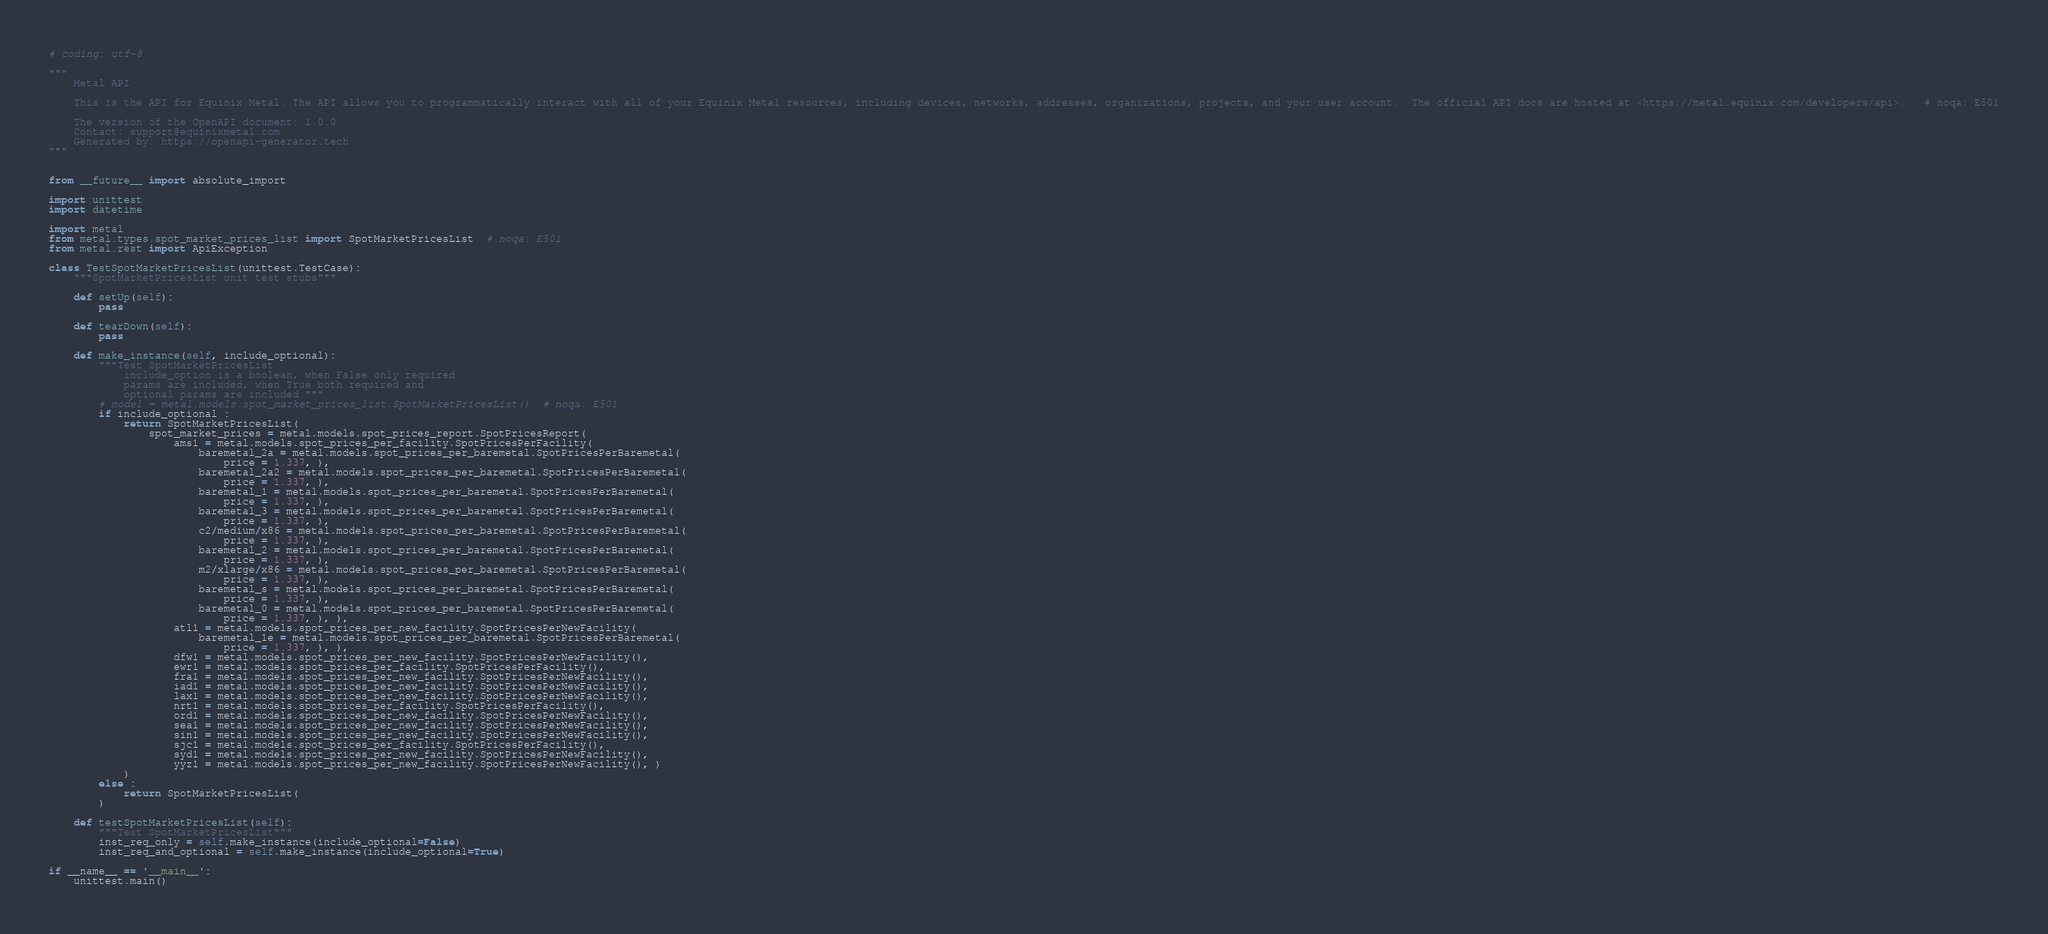<code> <loc_0><loc_0><loc_500><loc_500><_Python_># coding: utf-8

"""
    Metal API

    This is the API for Equinix Metal. The API allows you to programmatically interact with all of your Equinix Metal resources, including devices, networks, addresses, organizations, projects, and your user account.  The official API docs are hosted at <https://metal.equinix.com/developers/api>.   # noqa: E501

    The version of the OpenAPI document: 1.0.0
    Contact: support@equinixmetal.com
    Generated by: https://openapi-generator.tech
"""


from __future__ import absolute_import

import unittest
import datetime

import metal
from metal.types.spot_market_prices_list import SpotMarketPricesList  # noqa: E501
from metal.rest import ApiException

class TestSpotMarketPricesList(unittest.TestCase):
    """SpotMarketPricesList unit test stubs"""

    def setUp(self):
        pass

    def tearDown(self):
        pass

    def make_instance(self, include_optional):
        """Test SpotMarketPricesList
            include_option is a boolean, when False only required
            params are included, when True both required and
            optional params are included """
        # model = metal.models.spot_market_prices_list.SpotMarketPricesList()  # noqa: E501
        if include_optional :
            return SpotMarketPricesList(
                spot_market_prices = metal.models.spot_prices_report.SpotPricesReport(
                    ams1 = metal.models.spot_prices_per_facility.SpotPricesPerFacility(
                        baremetal_2a = metal.models.spot_prices_per_baremetal.SpotPricesPerBaremetal(
                            price = 1.337, ), 
                        baremetal_2a2 = metal.models.spot_prices_per_baremetal.SpotPricesPerBaremetal(
                            price = 1.337, ), 
                        baremetal_1 = metal.models.spot_prices_per_baremetal.SpotPricesPerBaremetal(
                            price = 1.337, ), 
                        baremetal_3 = metal.models.spot_prices_per_baremetal.SpotPricesPerBaremetal(
                            price = 1.337, ), 
                        c2/medium/x86 = metal.models.spot_prices_per_baremetal.SpotPricesPerBaremetal(
                            price = 1.337, ), 
                        baremetal_2 = metal.models.spot_prices_per_baremetal.SpotPricesPerBaremetal(
                            price = 1.337, ), 
                        m2/xlarge/x86 = metal.models.spot_prices_per_baremetal.SpotPricesPerBaremetal(
                            price = 1.337, ), 
                        baremetal_s = metal.models.spot_prices_per_baremetal.SpotPricesPerBaremetal(
                            price = 1.337, ), 
                        baremetal_0 = metal.models.spot_prices_per_baremetal.SpotPricesPerBaremetal(
                            price = 1.337, ), ), 
                    atl1 = metal.models.spot_prices_per_new_facility.SpotPricesPerNewFacility(
                        baremetal_1e = metal.models.spot_prices_per_baremetal.SpotPricesPerBaremetal(
                            price = 1.337, ), ), 
                    dfw1 = metal.models.spot_prices_per_new_facility.SpotPricesPerNewFacility(), 
                    ewr1 = metal.models.spot_prices_per_facility.SpotPricesPerFacility(), 
                    fra1 = metal.models.spot_prices_per_new_facility.SpotPricesPerNewFacility(), 
                    iad1 = metal.models.spot_prices_per_new_facility.SpotPricesPerNewFacility(), 
                    lax1 = metal.models.spot_prices_per_new_facility.SpotPricesPerNewFacility(), 
                    nrt1 = metal.models.spot_prices_per_facility.SpotPricesPerFacility(), 
                    ord1 = metal.models.spot_prices_per_new_facility.SpotPricesPerNewFacility(), 
                    sea1 = metal.models.spot_prices_per_new_facility.SpotPricesPerNewFacility(), 
                    sin1 = metal.models.spot_prices_per_new_facility.SpotPricesPerNewFacility(), 
                    sjc1 = metal.models.spot_prices_per_facility.SpotPricesPerFacility(), 
                    syd1 = metal.models.spot_prices_per_new_facility.SpotPricesPerNewFacility(), 
                    yyz1 = metal.models.spot_prices_per_new_facility.SpotPricesPerNewFacility(), )
            )
        else :
            return SpotMarketPricesList(
        )

    def testSpotMarketPricesList(self):
        """Test SpotMarketPricesList"""
        inst_req_only = self.make_instance(include_optional=False)
        inst_req_and_optional = self.make_instance(include_optional=True)

if __name__ == '__main__':
    unittest.main()
</code> 